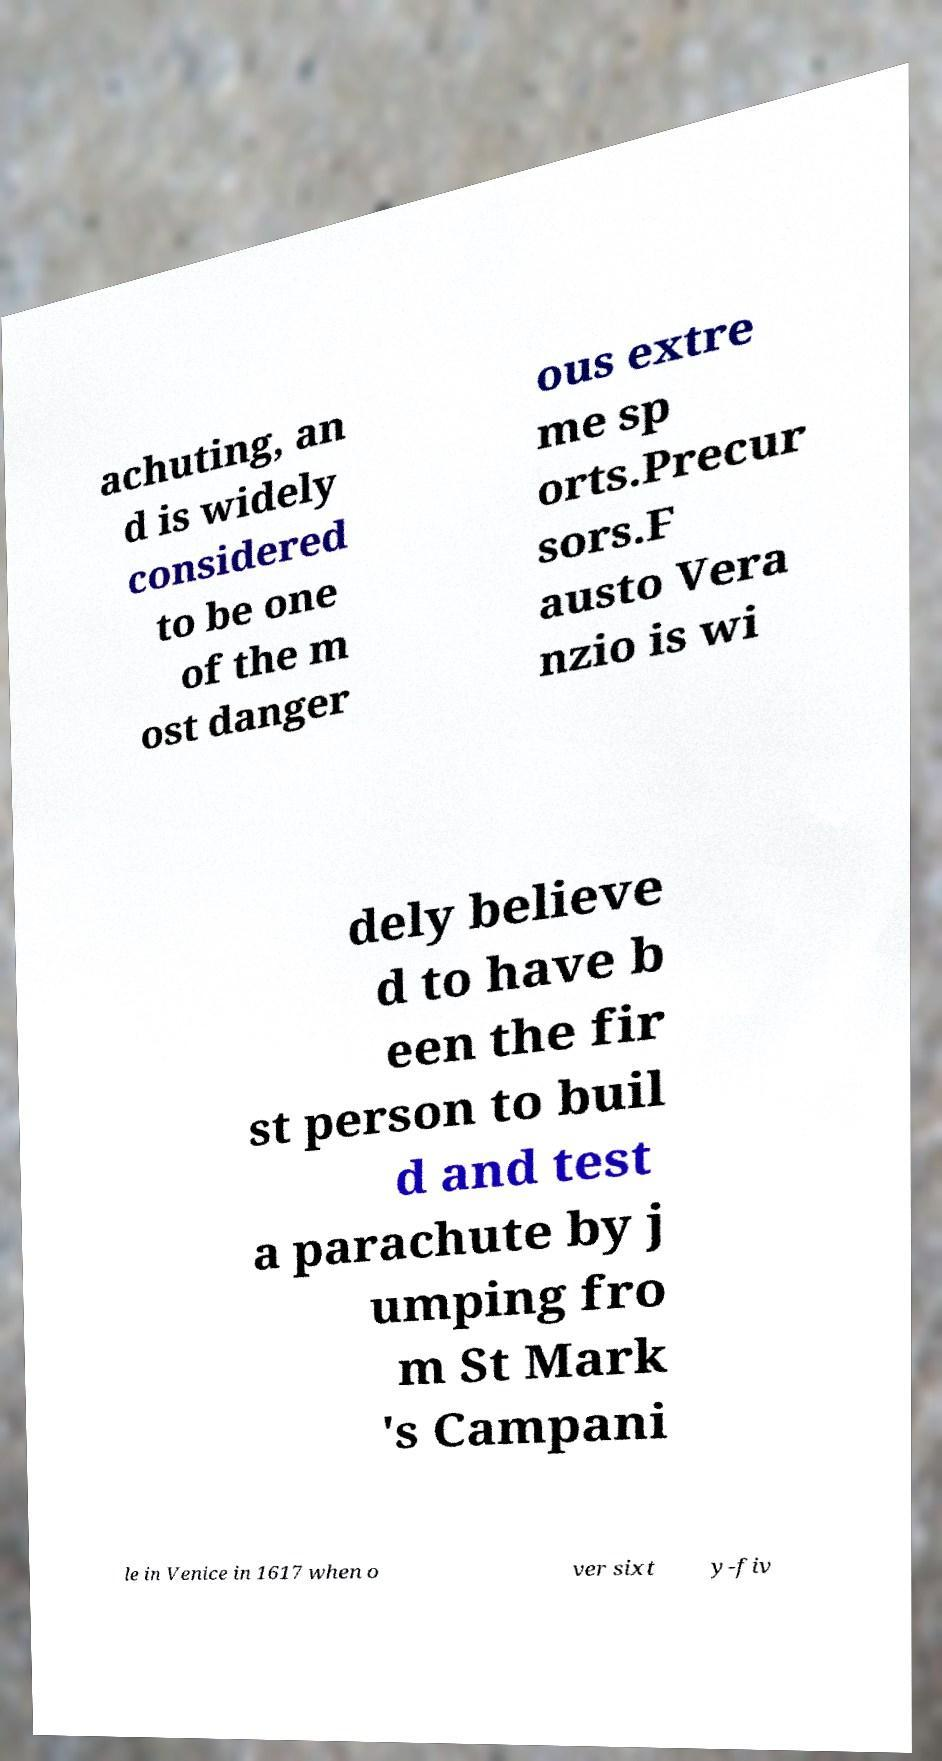There's text embedded in this image that I need extracted. Can you transcribe it verbatim? achuting, an d is widely considered to be one of the m ost danger ous extre me sp orts.Precur sors.F austo Vera nzio is wi dely believe d to have b een the fir st person to buil d and test a parachute by j umping fro m St Mark 's Campani le in Venice in 1617 when o ver sixt y-fiv 